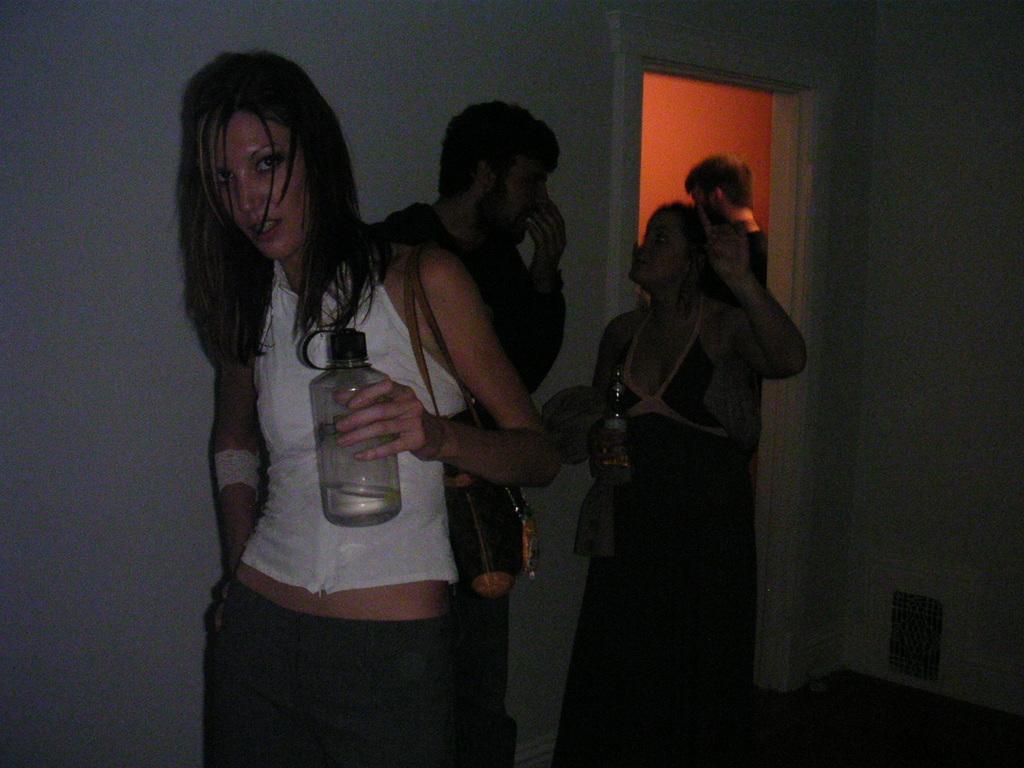Could you give a brief overview of what you see in this image? In this picture we can see girl wearing white top and a bag on the shoulder, holding the water bottle in the hand and giving the pose into the camera. Behind we can see a boy wearing black jacket is arguing with the girl beside her standing in the black dress. In the background we can see the a white door and a room in which man is standing in that room. 